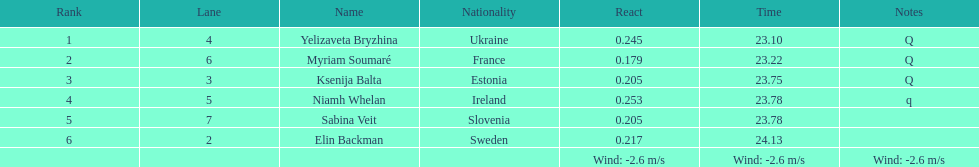The difference between yelizaveta bryzhina's time and ksenija balta's time? 0.65. 